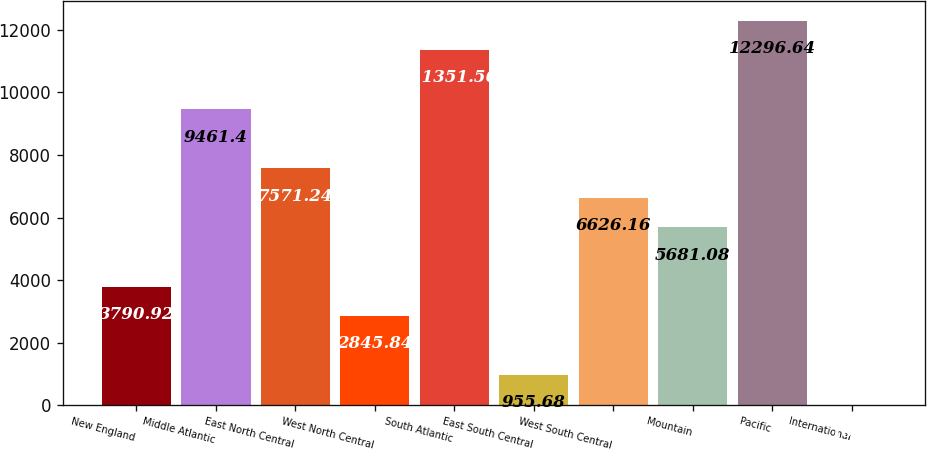<chart> <loc_0><loc_0><loc_500><loc_500><bar_chart><fcel>New England<fcel>Middle Atlantic<fcel>East North Central<fcel>West North Central<fcel>South Atlantic<fcel>East South Central<fcel>West South Central<fcel>Mountain<fcel>Pacific<fcel>International<nl><fcel>3790.92<fcel>9461.4<fcel>7571.24<fcel>2845.84<fcel>11351.6<fcel>955.68<fcel>6626.16<fcel>5681.08<fcel>12296.6<fcel>10.6<nl></chart> 